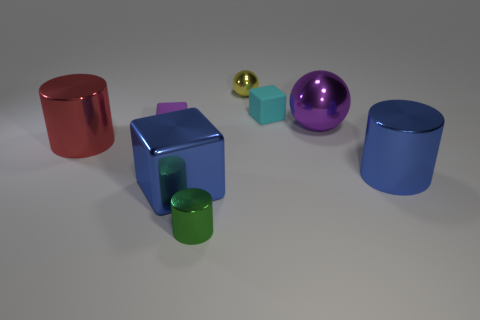Add 1 cyan blocks. How many objects exist? 9 Subtract all tiny cubes. How many cubes are left? 1 Subtract all purple balls. How many balls are left? 1 Subtract 0 brown spheres. How many objects are left? 8 Subtract all cylinders. How many objects are left? 5 Subtract all brown cylinders. Subtract all cyan balls. How many cylinders are left? 3 Subtract all small red rubber balls. Subtract all cyan cubes. How many objects are left? 7 Add 6 purple matte cubes. How many purple matte cubes are left? 7 Add 8 matte objects. How many matte objects exist? 10 